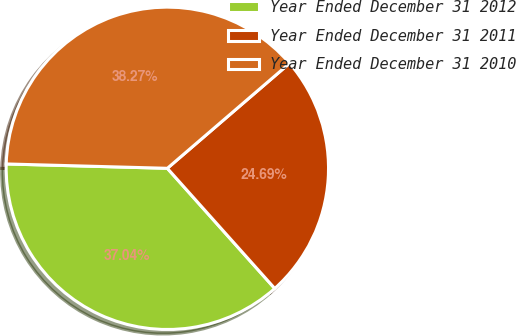Convert chart to OTSL. <chart><loc_0><loc_0><loc_500><loc_500><pie_chart><fcel>Year Ended December 31 2012<fcel>Year Ended December 31 2011<fcel>Year Ended December 31 2010<nl><fcel>37.04%<fcel>24.69%<fcel>38.27%<nl></chart> 